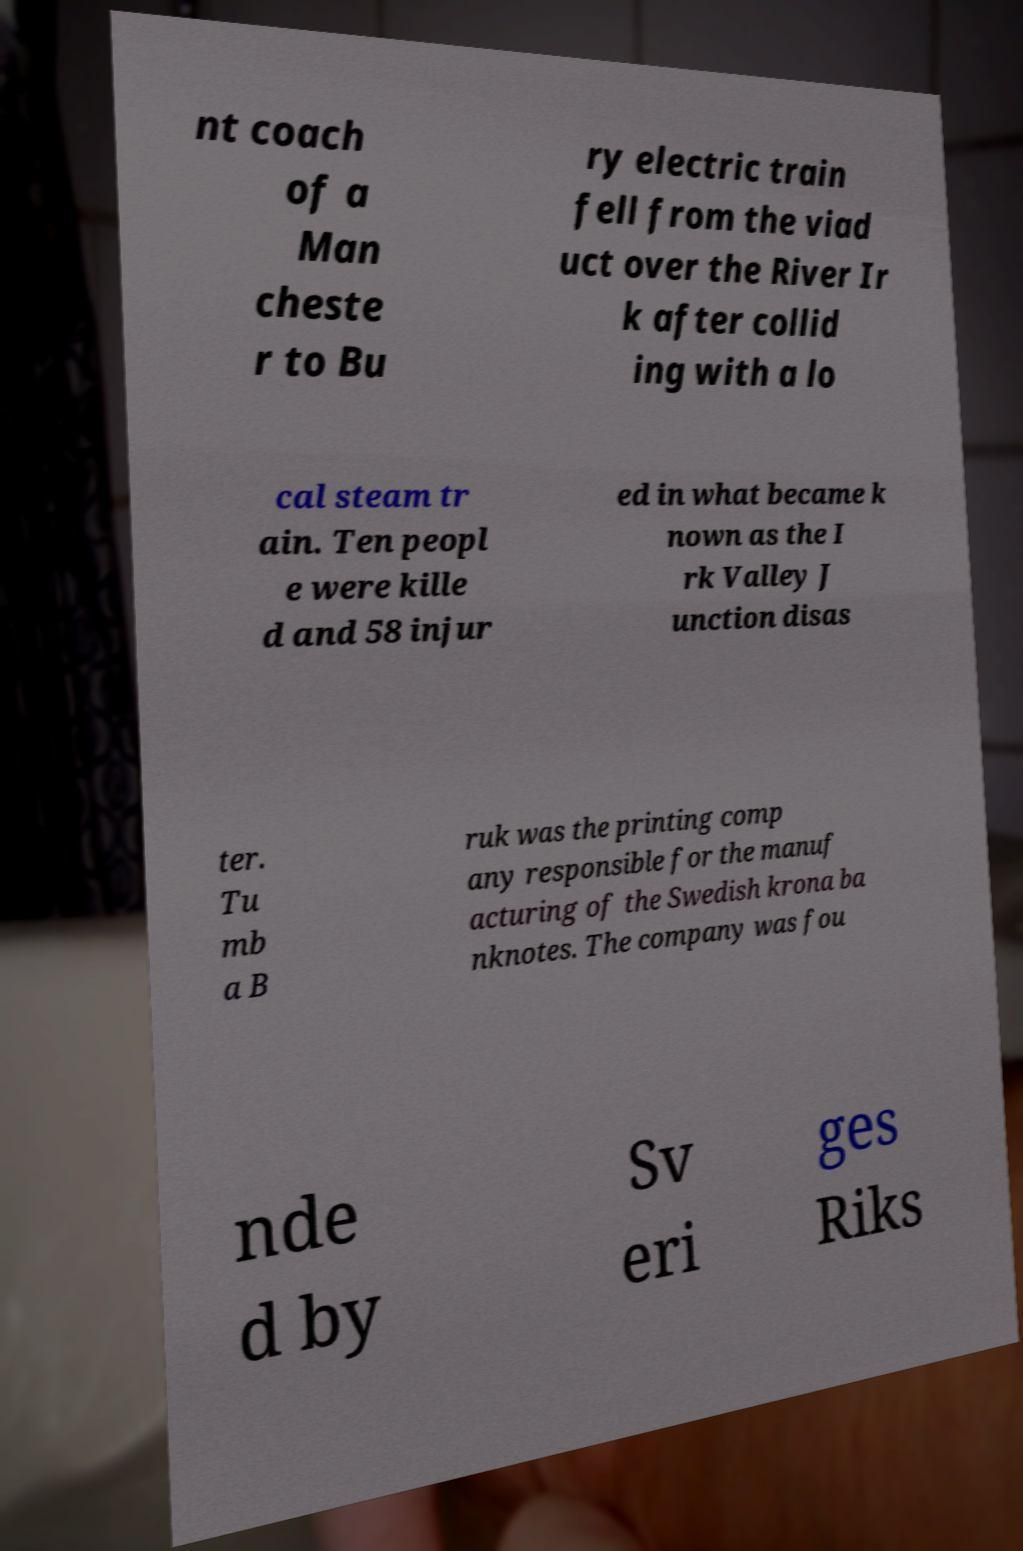Can you read and provide the text displayed in the image?This photo seems to have some interesting text. Can you extract and type it out for me? nt coach of a Man cheste r to Bu ry electric train fell from the viad uct over the River Ir k after collid ing with a lo cal steam tr ain. Ten peopl e were kille d and 58 injur ed in what became k nown as the I rk Valley J unction disas ter. Tu mb a B ruk was the printing comp any responsible for the manuf acturing of the Swedish krona ba nknotes. The company was fou nde d by Sv eri ges Riks 